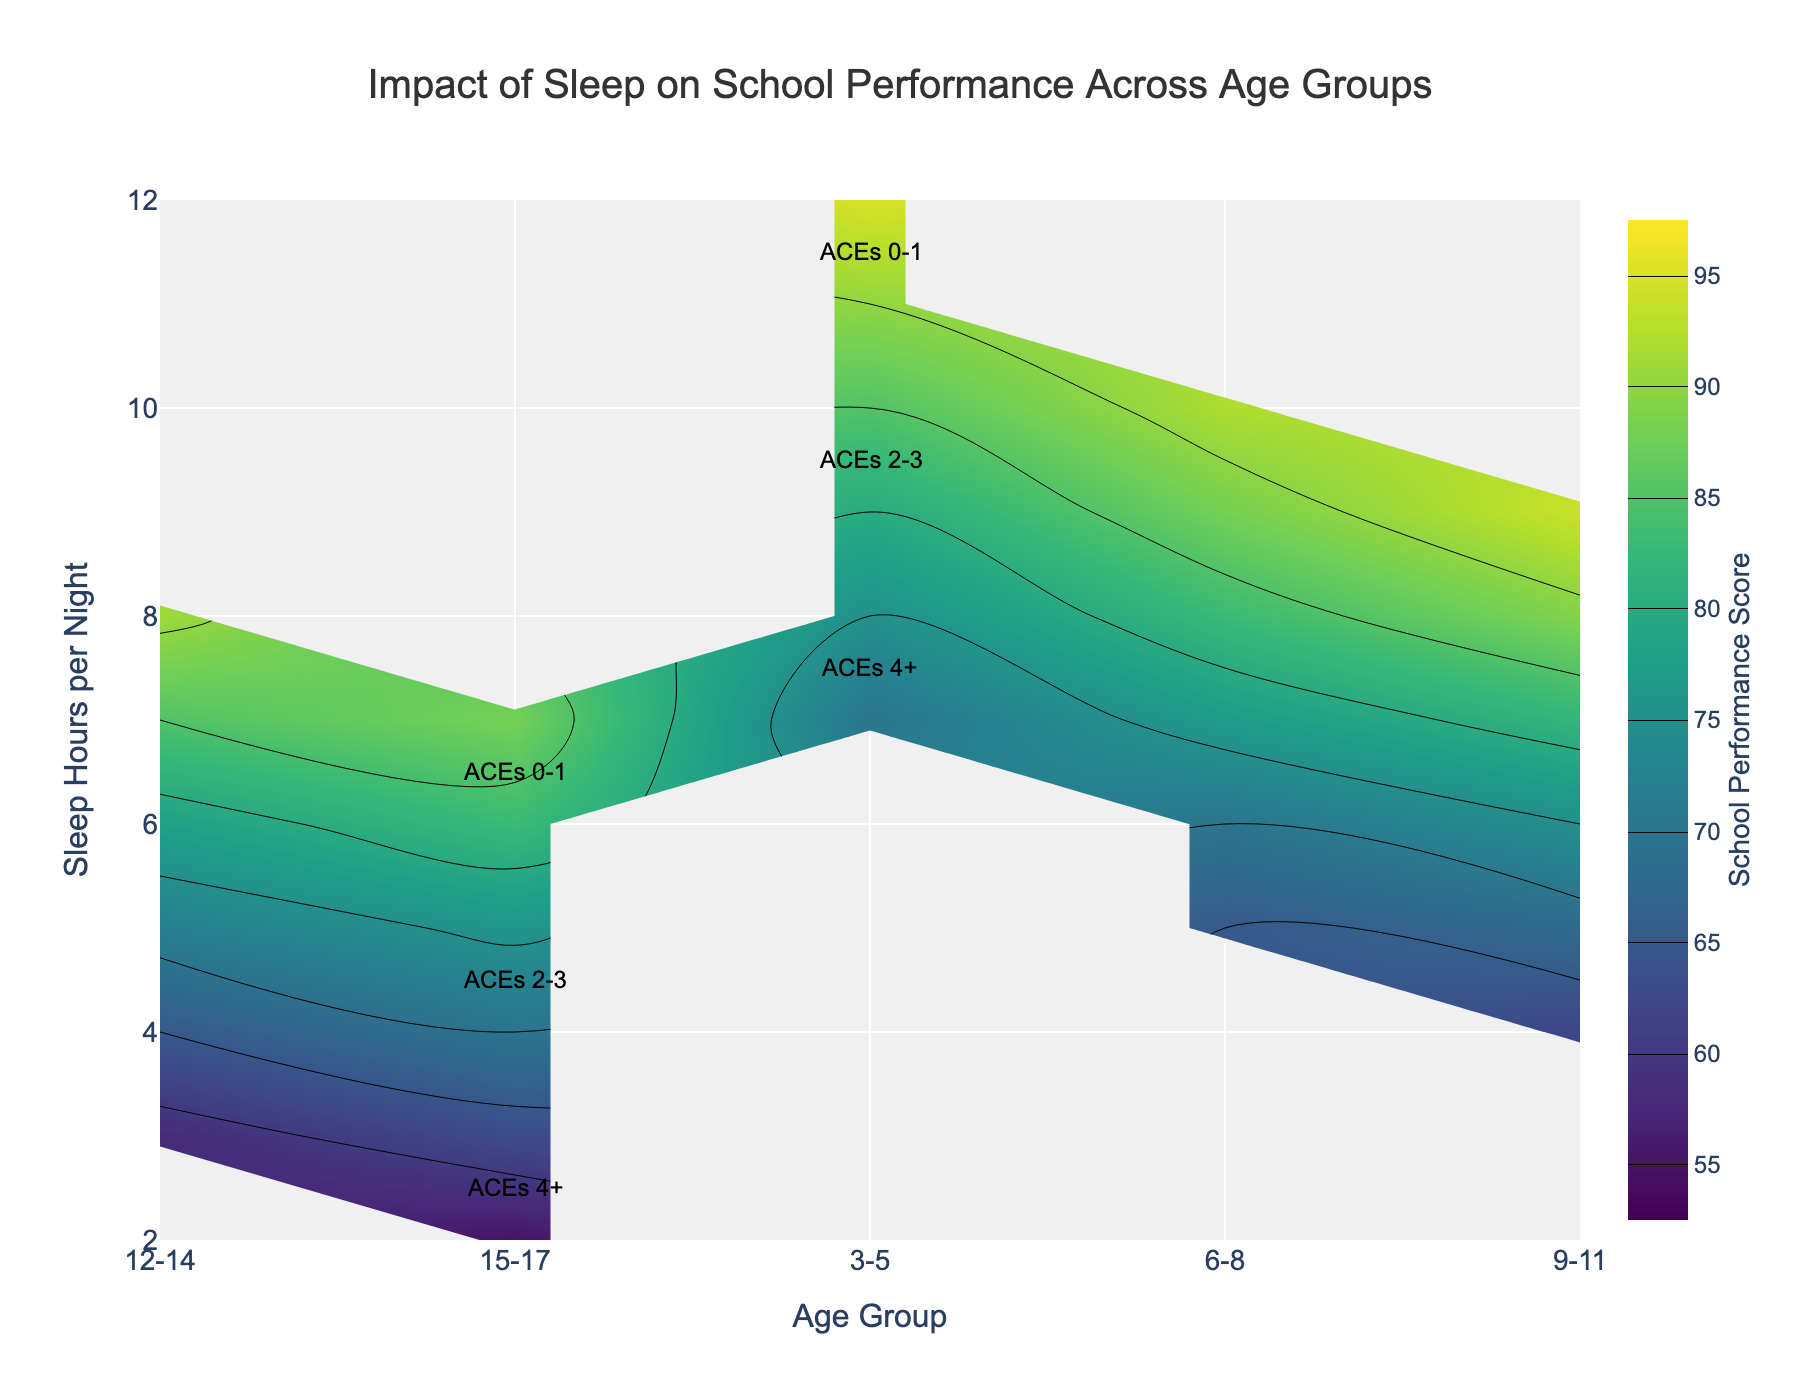What is the title of the graph? The title of the graph is prominently displayed at the top of the figure. It helps to understand the subject matter of the graph.
Answer: Impact of Sleep on School Performance Across Age Groups What range of school performance scores does the color bar cover? The range is indicated on the color bar present on the right side of the contour plot which provides context for interpreting the color gradients in the figure.
Answer: 55 to 95 At what sleep hours per night do children aged 3-5 with 0-1 ACEs achieve a school performance score of around 90? The hovertemplate and annotations in the 3-5 age group section reveal the corresponding school performance score for different sleep hours per night.
Answer: 11 Which age group shows the highest school performance score for children with 4+ ACEs? Using the annotations and contour levels, we can identify the age group linked to the highest performance scores among children with 4+ ACEs.
Answer: 3-5 How does school performance change in the 6-8 age group as sleep hours decrease from 10 to 5? By tracing the contour lines for the 6-8 age group from higher to lower sleep hours, we can observe the performance changes.
Answer: It decreases from 92 to 65 In the 9-11 age group, is there a difference in school performance between children with 0-1 ACEs and those with 2-3 ACEs when sleeping 9 hours per night? The hovertemplate and color gradients provide school performance scores for different ACEs levels corresponding to specific sleep hours.
Answer: Yes, 94 for 0-1 ACEs and 82 for 2-3 ACEs What pattern is observed in school performance for children aged 15-17 with increasing ACEs score? Reviewing the annotations and color gradients for the 15-17 age group reveals the pattern in school performance as ACEs score increases.
Answer: Performance decreases with higher ACEs score Compare the school performance at 7 hours of sleep between age groups 6-8 and 12-14. By checking the color levels and hovertemplate at 7 hours of sleep for both age groups, we can compare their school performances.
Answer: 77 for 6-8 and 85 for 12-14 At what sleep hours per night do children aged 12-14 with 2-3 ACEs typically achieve a school performance score around 78? Refer to the contour level and hovertemplate in the 12-14 age group section to find the specific sleep hours correlating with a score of 78 for 2-3 ACEs.
Answer: 6 What is the general relationship between sleep hours per night and school performance scores across all age groups? By observing the general trend in the figure's color gradients and contours, we discern the effect of sleep hours on school performance.
Answer: More sleep leads to better performance 